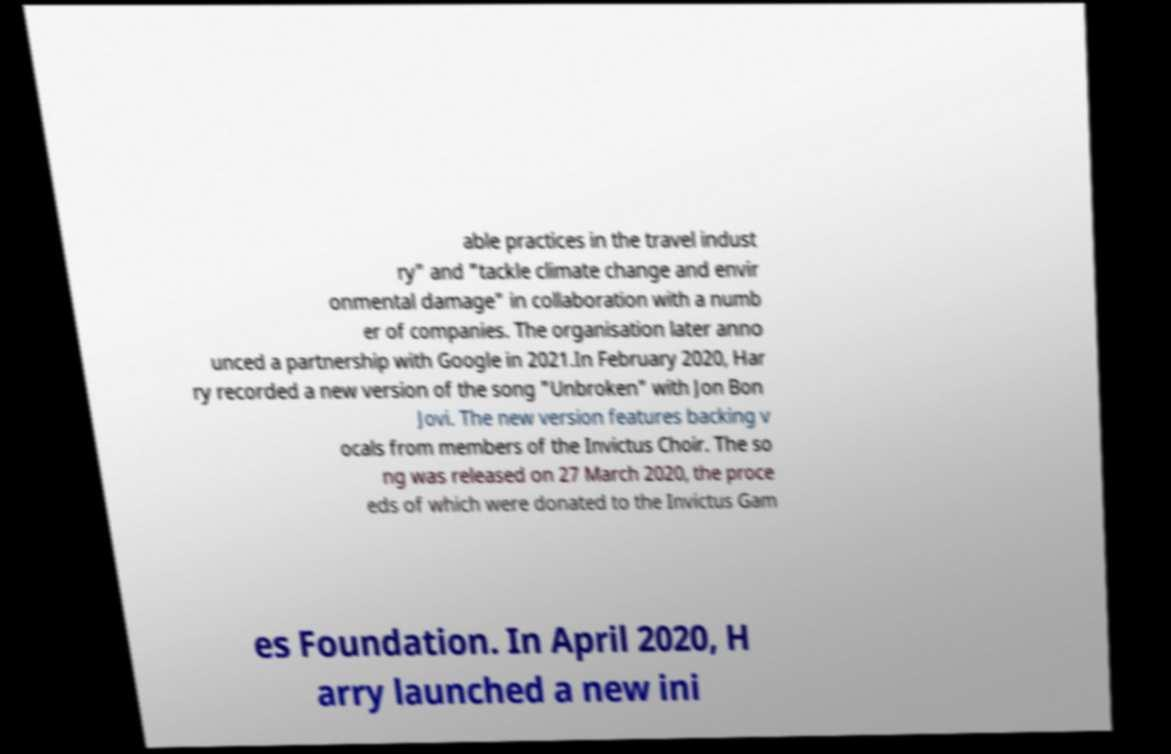Please read and relay the text visible in this image. What does it say? able practices in the travel indust ry" and "tackle climate change and envir onmental damage" in collaboration with a numb er of companies. The organisation later anno unced a partnership with Google in 2021.In February 2020, Har ry recorded a new version of the song "Unbroken" with Jon Bon Jovi. The new version features backing v ocals from members of the Invictus Choir. The so ng was released on 27 March 2020, the proce eds of which were donated to the Invictus Gam es Foundation. In April 2020, H arry launched a new ini 